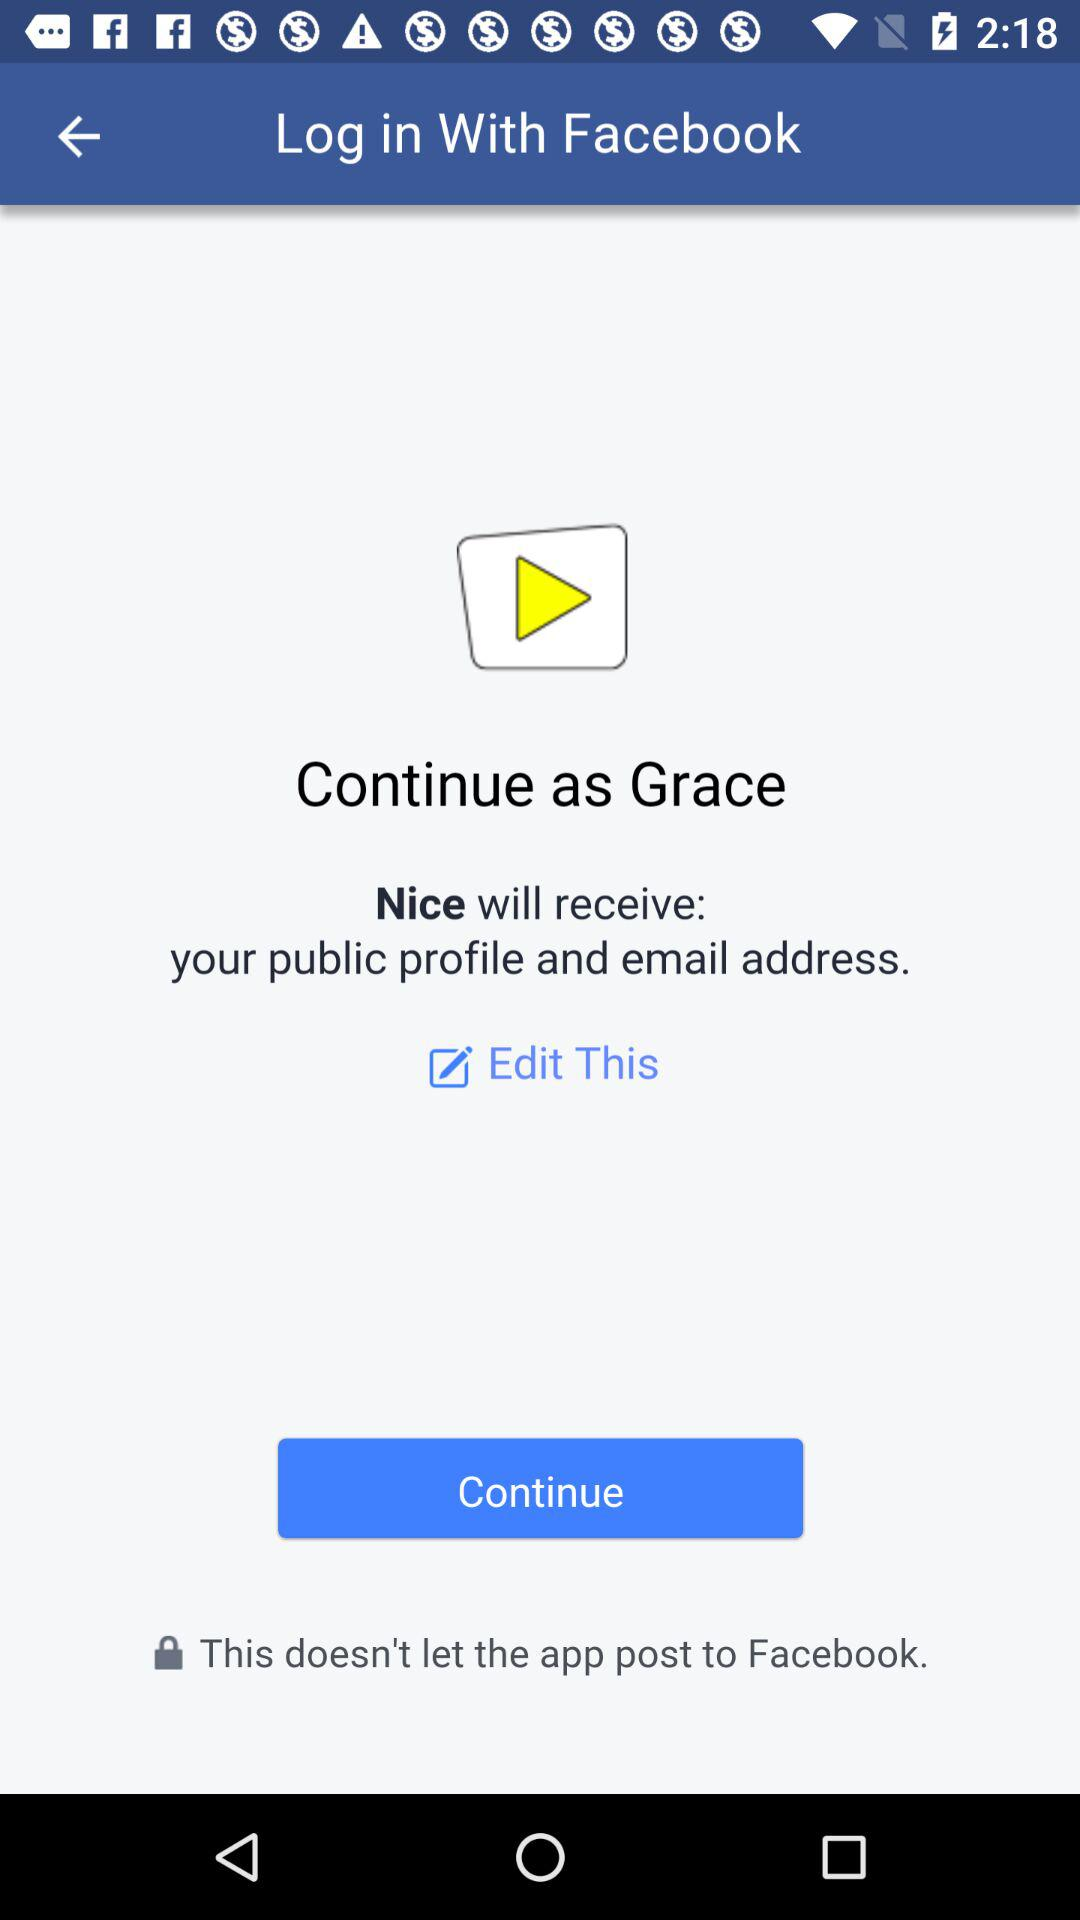What is the name of the user? The name of the user is Grace. 